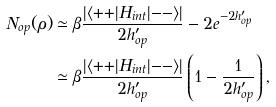<formula> <loc_0><loc_0><loc_500><loc_500>N _ { o p } ( \rho ) & \simeq \beta \frac { | \langle { + + } | H _ { i n t } | { - - } \rangle | } { 2 h ^ { \prime } _ { o p } } - 2 e ^ { - 2 h ^ { \prime } _ { o p } } \\ & \simeq \beta \frac { | \langle { + + } | H _ { i n t } | { - - } \rangle | } { 2 h ^ { \prime } _ { o p } } \left ( 1 - \frac { 1 } { 2 h ^ { \prime } _ { o p } } \right ) ,</formula> 